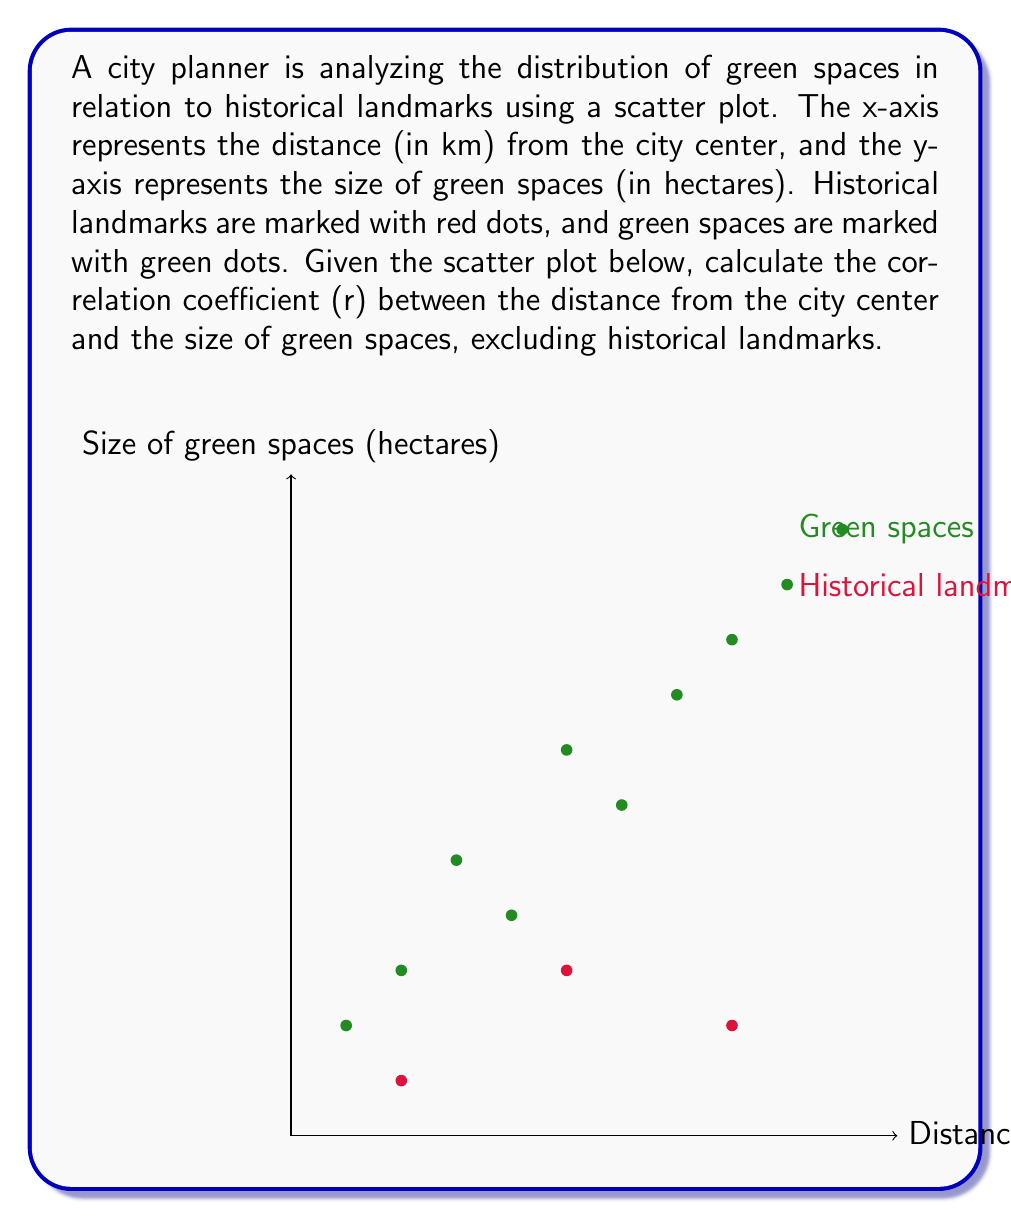What is the answer to this math problem? To calculate the correlation coefficient (r) between the distance from the city center and the size of green spaces, excluding historical landmarks, we'll follow these steps:

1) First, we need to identify the data points for green spaces:
   x: {1, 2, 3, 4, 5, 6, 7, 8, 9, 10}
   y: {2, 3, 5, 4, 7, 6, 8, 9, 10, 11}

2) Calculate the means:
   $\bar{x} = \frac{1 + 2 + 3 + 4 + 5 + 6 + 7 + 8 + 9 + 10}{10} = 5.5$
   $\bar{y} = \frac{2 + 3 + 5 + 4 + 7 + 6 + 8 + 9 + 10 + 11}{10} = 6.5$

3) Calculate the deviations from the mean:
   x - $\bar{x}$: {-4.5, -3.5, -2.5, -1.5, -0.5, 0.5, 1.5, 2.5, 3.5, 4.5}
   y - $\bar{y}$: {-4.5, -3.5, -1.5, -2.5, 0.5, -0.5, 1.5, 2.5, 3.5, 4.5}

4) Calculate the products of the deviations:
   (x - $\bar{x}$)(y - $\bar{y}$): {20.25, 12.25, 3.75, 3.75, -0.25, -0.25, 2.25, 6.25, 12.25, 20.25}

5) Calculate the squares of the deviations:
   (x - $\bar{x}$)²: {20.25, 12.25, 6.25, 2.25, 0.25, 0.25, 2.25, 6.25, 12.25, 20.25}
   (y - $\bar{y}$)²: {20.25, 12.25, 2.25, 6.25, 0.25, 0.25, 2.25, 6.25, 12.25, 20.25}

6) Sum up the results:
   $\sum(x - \bar{x})(y - \bar{y}) = 80.5$
   $\sum(x - \bar{x})² = 82.5$
   $\sum(y - \bar{y})² = 82.5$

7) Apply the correlation coefficient formula:
   $$r = \frac{\sum(x - \bar{x})(y - \bar{y})}{\sqrt{\sum(x - \bar{x})²\sum(y - \bar{y})²}}$$
   
   $$r = \frac{80.5}{\sqrt{82.5 \times 82.5}} = \frac{80.5}{82.5} \approx 0.9758$$
Answer: $r \approx 0.9758$ 